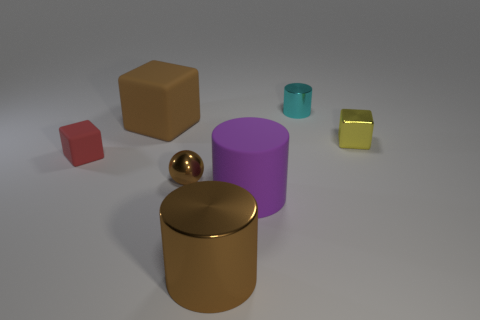Add 1 small gray things. How many objects exist? 8 Subtract all cylinders. How many objects are left? 4 Add 6 cyan cylinders. How many cyan cylinders exist? 7 Subtract 0 purple cubes. How many objects are left? 7 Subtract all small blue rubber things. Subtract all big matte objects. How many objects are left? 5 Add 1 brown cubes. How many brown cubes are left? 2 